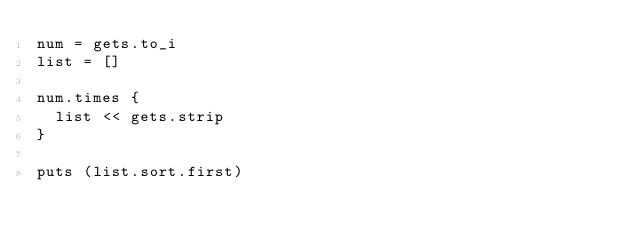Convert code to text. <code><loc_0><loc_0><loc_500><loc_500><_Ruby_>num = gets.to_i
list = []

num.times { 
  list << gets.strip
}

puts (list.sort.first)</code> 